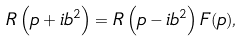<formula> <loc_0><loc_0><loc_500><loc_500>R \left ( p + i b ^ { 2 } \right ) = R \left ( p - i b ^ { 2 } \right ) F ( p ) ,</formula> 